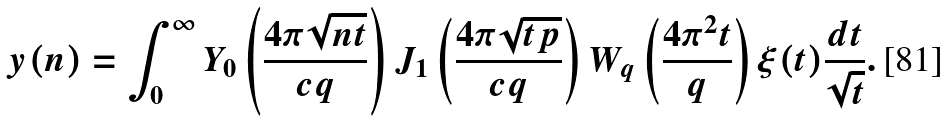<formula> <loc_0><loc_0><loc_500><loc_500>y ( n ) = \int _ { 0 } ^ { \infty } Y _ { 0 } \left ( \frac { 4 \pi \sqrt { n t } } { c q } \right ) J _ { 1 } \left ( \frac { 4 \pi \sqrt { t p } } { c q } \right ) W _ { q } \left ( \frac { 4 \pi ^ { 2 } t } { q } \right ) \xi ( t ) \frac { d t } { \sqrt { t } } .</formula> 